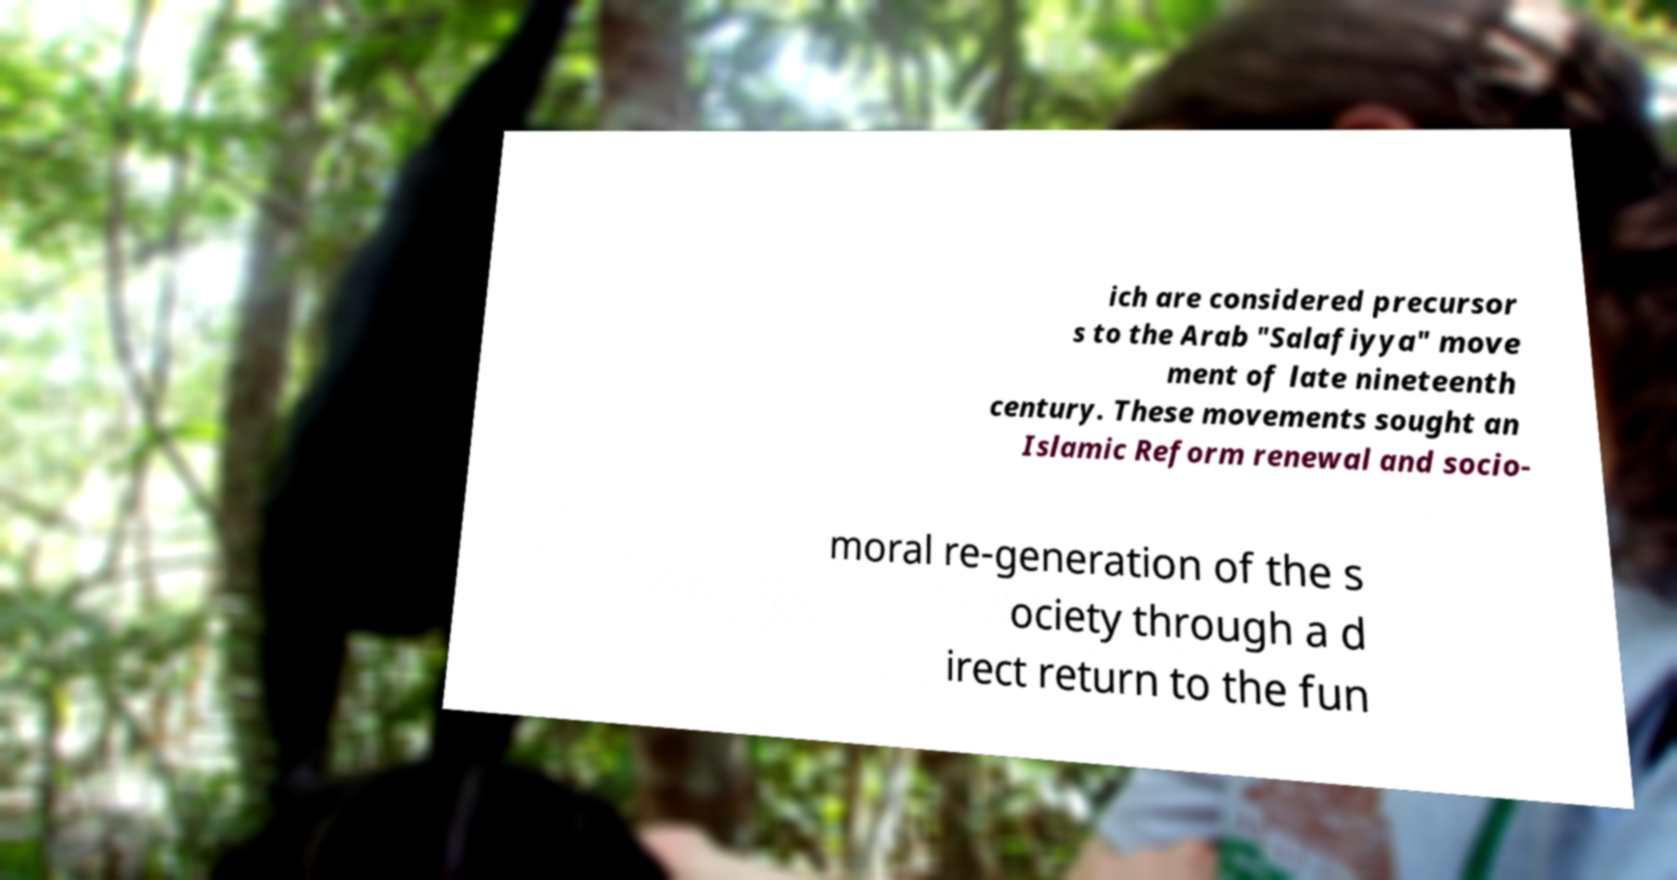Could you extract and type out the text from this image? ich are considered precursor s to the Arab "Salafiyya" move ment of late nineteenth century. These movements sought an Islamic Reform renewal and socio- moral re-generation of the s ociety through a d irect return to the fun 